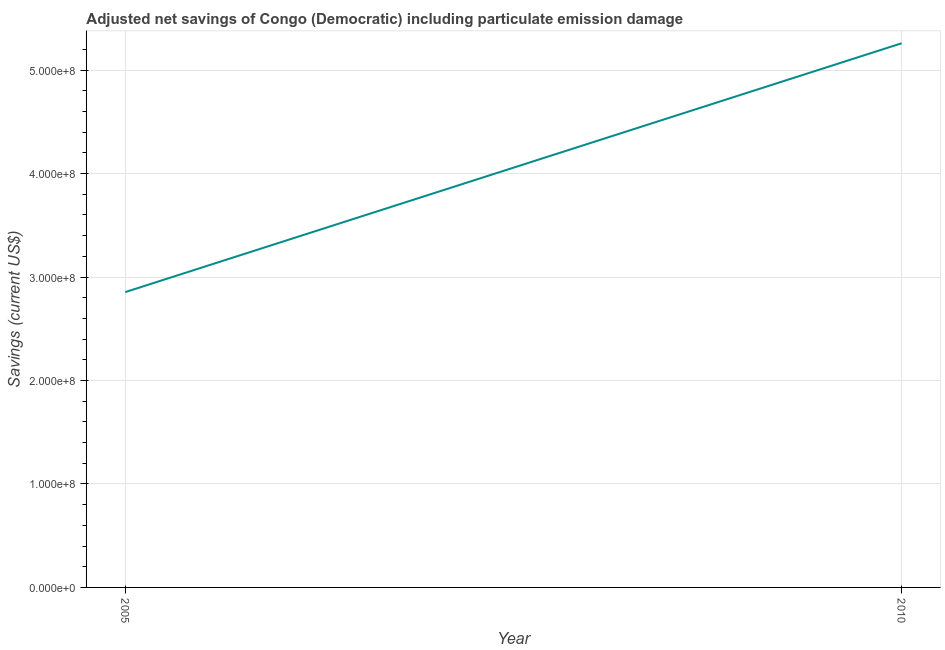What is the adjusted net savings in 2005?
Your response must be concise. 2.85e+08. Across all years, what is the maximum adjusted net savings?
Ensure brevity in your answer.  5.26e+08. Across all years, what is the minimum adjusted net savings?
Your answer should be compact. 2.85e+08. What is the sum of the adjusted net savings?
Provide a succinct answer. 8.11e+08. What is the difference between the adjusted net savings in 2005 and 2010?
Offer a terse response. -2.40e+08. What is the average adjusted net savings per year?
Offer a very short reply. 4.06e+08. What is the median adjusted net savings?
Offer a very short reply. 4.06e+08. Do a majority of the years between 2010 and 2005 (inclusive) have adjusted net savings greater than 480000000 US$?
Offer a very short reply. No. What is the ratio of the adjusted net savings in 2005 to that in 2010?
Your response must be concise. 0.54. How many years are there in the graph?
Your response must be concise. 2. Are the values on the major ticks of Y-axis written in scientific E-notation?
Your answer should be compact. Yes. Does the graph contain grids?
Your answer should be compact. Yes. What is the title of the graph?
Your answer should be compact. Adjusted net savings of Congo (Democratic) including particulate emission damage. What is the label or title of the Y-axis?
Make the answer very short. Savings (current US$). What is the Savings (current US$) in 2005?
Keep it short and to the point. 2.85e+08. What is the Savings (current US$) in 2010?
Offer a terse response. 5.26e+08. What is the difference between the Savings (current US$) in 2005 and 2010?
Your answer should be compact. -2.40e+08. What is the ratio of the Savings (current US$) in 2005 to that in 2010?
Offer a very short reply. 0.54. 